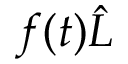<formula> <loc_0><loc_0><loc_500><loc_500>f ( t ) \hat { L }</formula> 